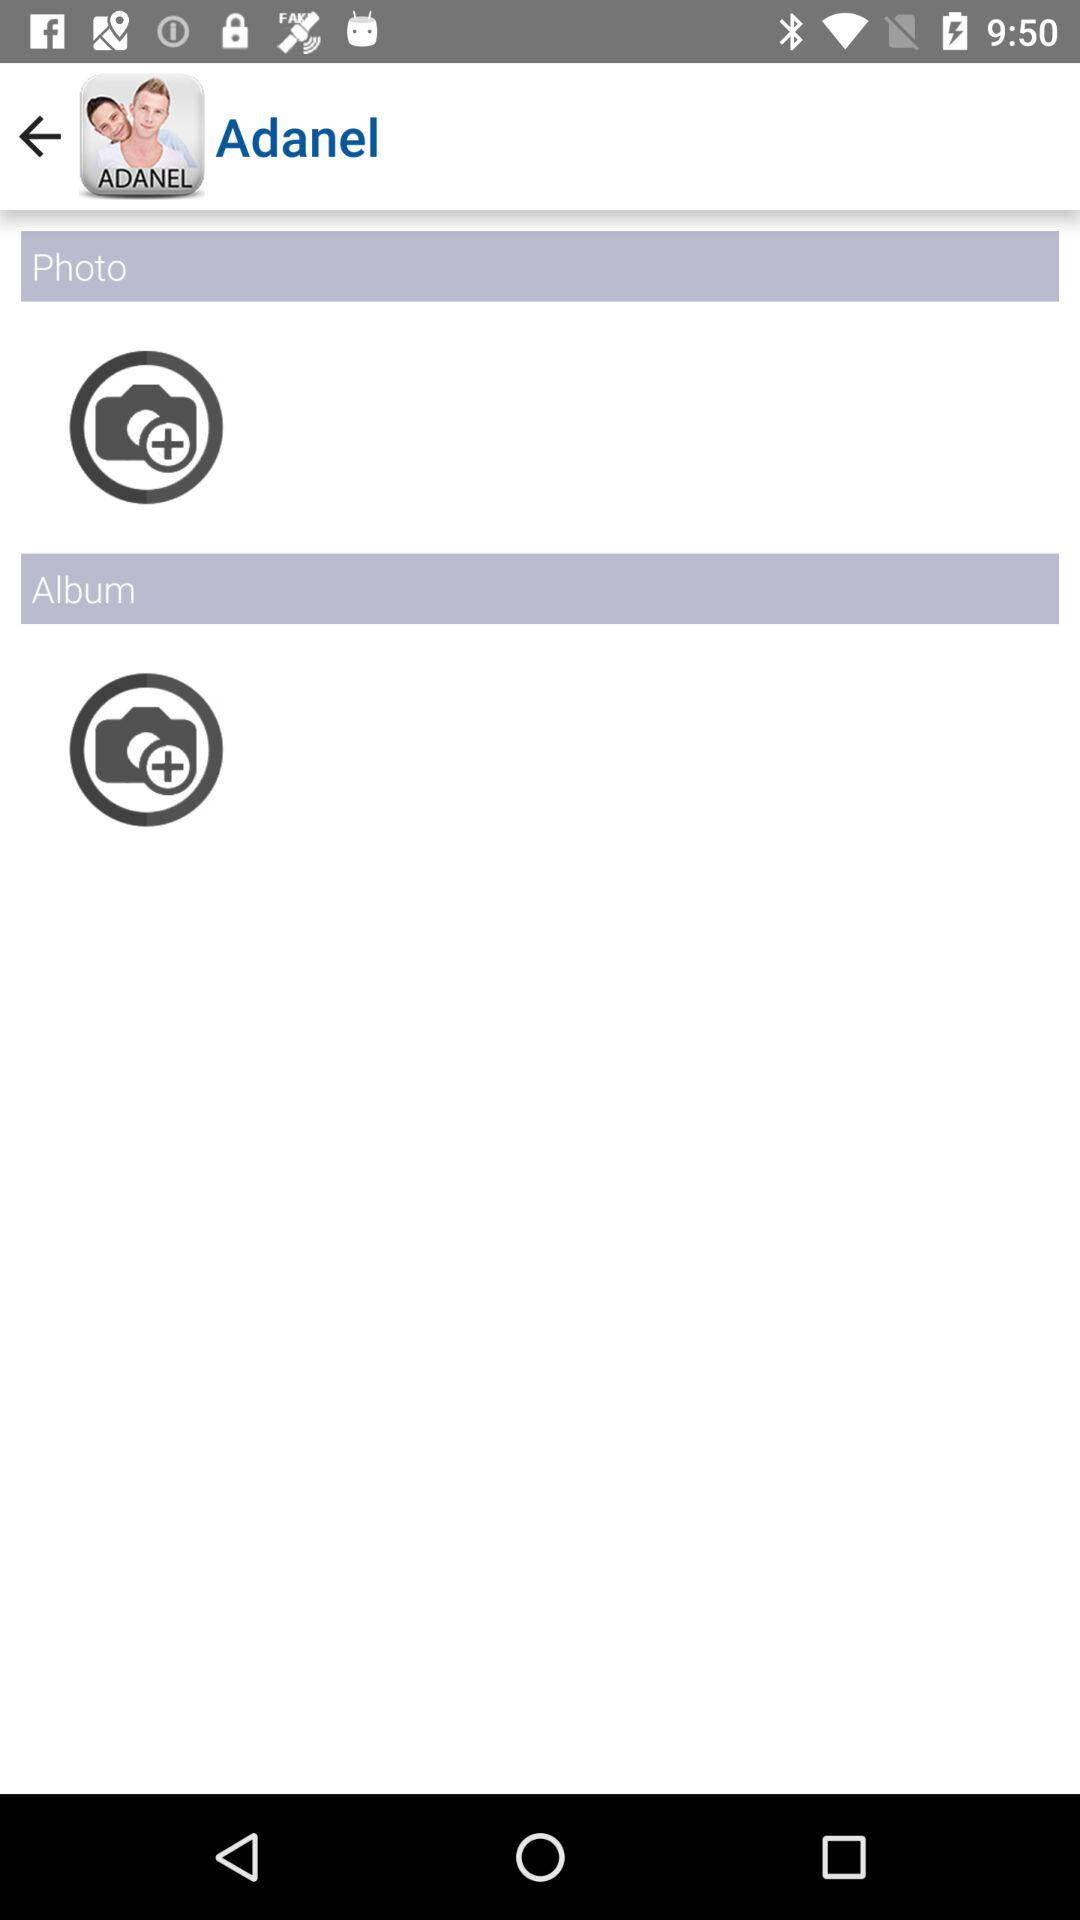What is the user name? The user name is Adanel. 